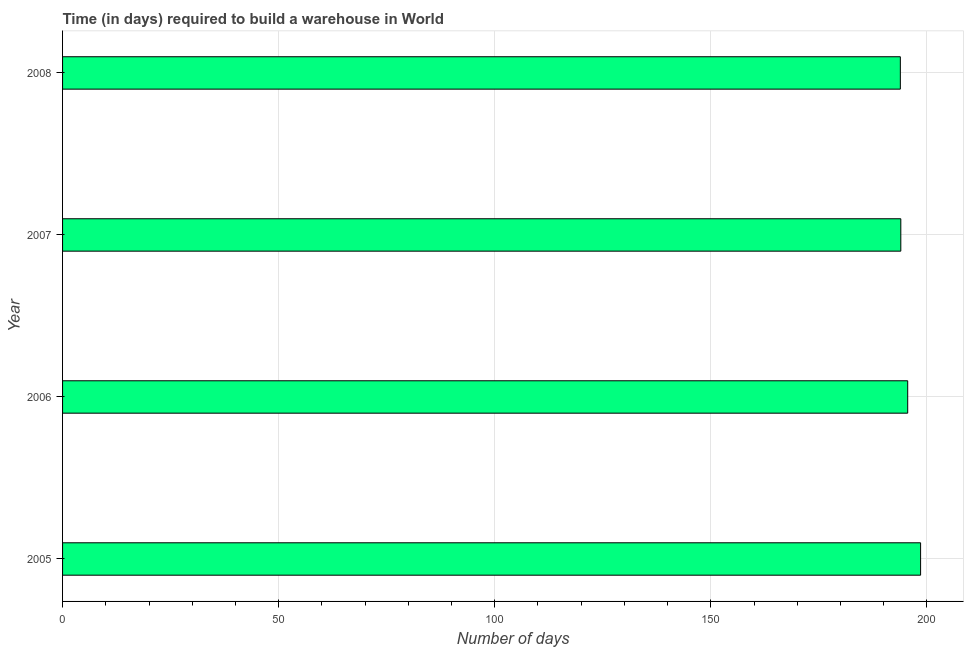Does the graph contain any zero values?
Your answer should be very brief. No. Does the graph contain grids?
Make the answer very short. Yes. What is the title of the graph?
Your answer should be very brief. Time (in days) required to build a warehouse in World. What is the label or title of the X-axis?
Your answer should be compact. Number of days. What is the label or title of the Y-axis?
Your response must be concise. Year. What is the time required to build a warehouse in 2008?
Give a very brief answer. 193.84. Across all years, what is the maximum time required to build a warehouse?
Provide a short and direct response. 198.53. Across all years, what is the minimum time required to build a warehouse?
Offer a very short reply. 193.84. In which year was the time required to build a warehouse maximum?
Offer a terse response. 2005. In which year was the time required to build a warehouse minimum?
Provide a short and direct response. 2008. What is the sum of the time required to build a warehouse?
Your answer should be very brief. 781.87. What is the difference between the time required to build a warehouse in 2006 and 2007?
Your answer should be very brief. 1.59. What is the average time required to build a warehouse per year?
Your response must be concise. 195.47. What is the median time required to build a warehouse?
Your answer should be compact. 194.75. In how many years, is the time required to build a warehouse greater than 30 days?
Your response must be concise. 4. Do a majority of the years between 2008 and 2007 (inclusive) have time required to build a warehouse greater than 110 days?
Offer a terse response. No. What is the ratio of the time required to build a warehouse in 2006 to that in 2008?
Make the answer very short. 1.01. Is the difference between the time required to build a warehouse in 2006 and 2008 greater than the difference between any two years?
Keep it short and to the point. No. What is the difference between the highest and the second highest time required to build a warehouse?
Provide a short and direct response. 2.98. Is the sum of the time required to build a warehouse in 2005 and 2007 greater than the maximum time required to build a warehouse across all years?
Your response must be concise. Yes. What is the difference between the highest and the lowest time required to build a warehouse?
Offer a terse response. 4.68. In how many years, is the time required to build a warehouse greater than the average time required to build a warehouse taken over all years?
Your answer should be compact. 2. How many bars are there?
Provide a short and direct response. 4. How many years are there in the graph?
Keep it short and to the point. 4. Are the values on the major ticks of X-axis written in scientific E-notation?
Ensure brevity in your answer.  No. What is the Number of days of 2005?
Your answer should be very brief. 198.53. What is the Number of days of 2006?
Your answer should be compact. 195.55. What is the Number of days of 2007?
Offer a terse response. 193.95. What is the Number of days of 2008?
Offer a terse response. 193.84. What is the difference between the Number of days in 2005 and 2006?
Your response must be concise. 2.98. What is the difference between the Number of days in 2005 and 2007?
Offer a very short reply. 4.58. What is the difference between the Number of days in 2005 and 2008?
Offer a terse response. 4.68. What is the difference between the Number of days in 2006 and 2007?
Offer a very short reply. 1.6. What is the difference between the Number of days in 2006 and 2008?
Your answer should be compact. 1.7. What is the difference between the Number of days in 2007 and 2008?
Keep it short and to the point. 0.11. What is the ratio of the Number of days in 2005 to that in 2008?
Give a very brief answer. 1.02. What is the ratio of the Number of days in 2006 to that in 2007?
Provide a succinct answer. 1.01. 